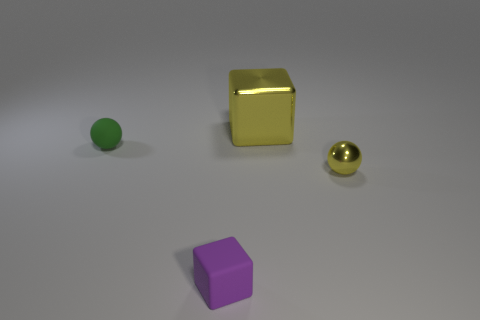Add 4 yellow shiny objects. How many objects exist? 8 Add 4 tiny brown blocks. How many tiny brown blocks exist? 4 Subtract 1 green balls. How many objects are left? 3 Subtract all small cyan metallic balls. Subtract all tiny yellow metallic things. How many objects are left? 3 Add 1 tiny things. How many tiny things are left? 4 